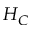Convert formula to latex. <formula><loc_0><loc_0><loc_500><loc_500>H _ { C }</formula> 